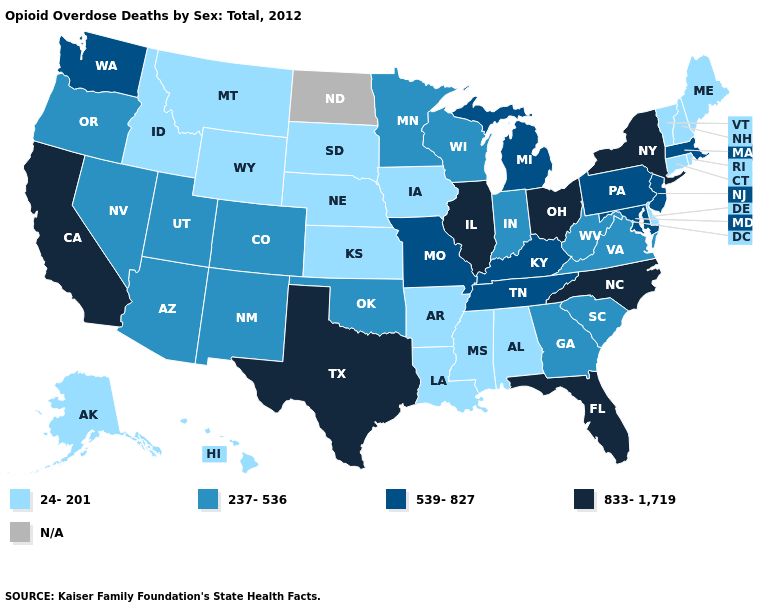Is the legend a continuous bar?
Concise answer only. No. Does the map have missing data?
Answer briefly. Yes. Which states have the highest value in the USA?
Concise answer only. California, Florida, Illinois, New York, North Carolina, Ohio, Texas. What is the lowest value in the Northeast?
Quick response, please. 24-201. What is the lowest value in states that border Georgia?
Answer briefly. 24-201. Among the states that border Kansas , which have the lowest value?
Be succinct. Nebraska. Does the map have missing data?
Short answer required. Yes. What is the value of North Dakota?
Answer briefly. N/A. What is the value of New Hampshire?
Quick response, please. 24-201. What is the lowest value in the USA?
Quick response, please. 24-201. What is the value of Florida?
Write a very short answer. 833-1,719. Name the states that have a value in the range 237-536?
Answer briefly. Arizona, Colorado, Georgia, Indiana, Minnesota, Nevada, New Mexico, Oklahoma, Oregon, South Carolina, Utah, Virginia, West Virginia, Wisconsin. Does Florida have the highest value in the South?
Write a very short answer. Yes. Which states have the lowest value in the South?
Short answer required. Alabama, Arkansas, Delaware, Louisiana, Mississippi. Does the first symbol in the legend represent the smallest category?
Short answer required. Yes. 